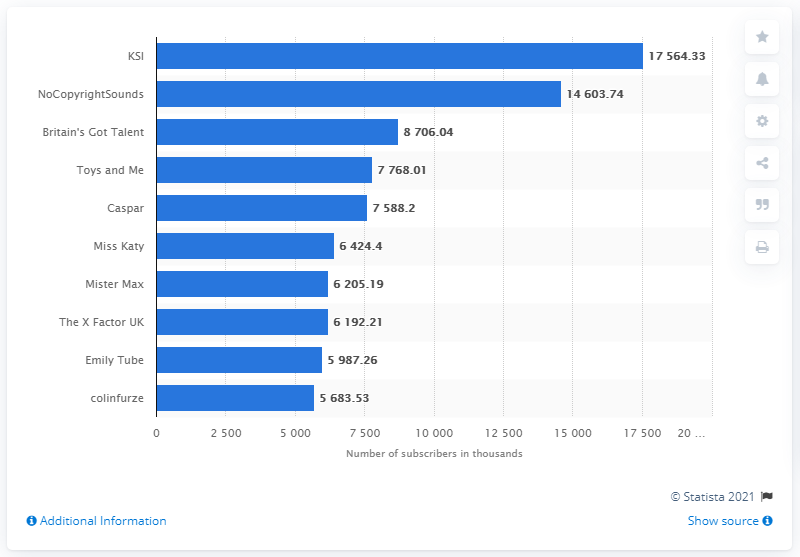List a handful of essential elements in this visual. KSI is the most subscribed YouTube channel in the UK. 